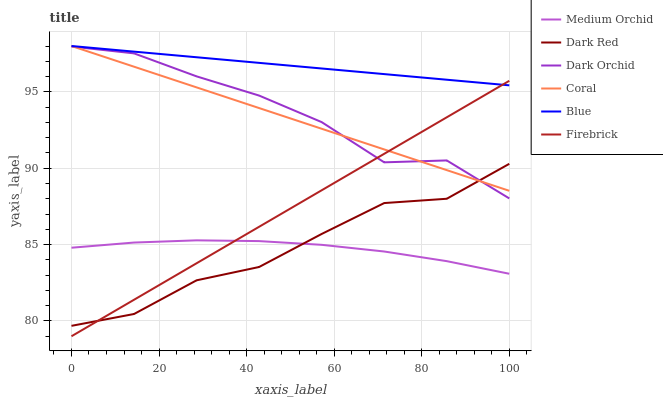Does Medium Orchid have the minimum area under the curve?
Answer yes or no. Yes. Does Blue have the maximum area under the curve?
Answer yes or no. Yes. Does Dark Red have the minimum area under the curve?
Answer yes or no. No. Does Dark Red have the maximum area under the curve?
Answer yes or no. No. Is Blue the smoothest?
Answer yes or no. Yes. Is Dark Orchid the roughest?
Answer yes or no. Yes. Is Dark Red the smoothest?
Answer yes or no. No. Is Dark Red the roughest?
Answer yes or no. No. Does Firebrick have the lowest value?
Answer yes or no. Yes. Does Dark Red have the lowest value?
Answer yes or no. No. Does Coral have the highest value?
Answer yes or no. Yes. Does Dark Red have the highest value?
Answer yes or no. No. Is Medium Orchid less than Dark Orchid?
Answer yes or no. Yes. Is Dark Orchid greater than Medium Orchid?
Answer yes or no. Yes. Does Blue intersect Firebrick?
Answer yes or no. Yes. Is Blue less than Firebrick?
Answer yes or no. No. Is Blue greater than Firebrick?
Answer yes or no. No. Does Medium Orchid intersect Dark Orchid?
Answer yes or no. No. 